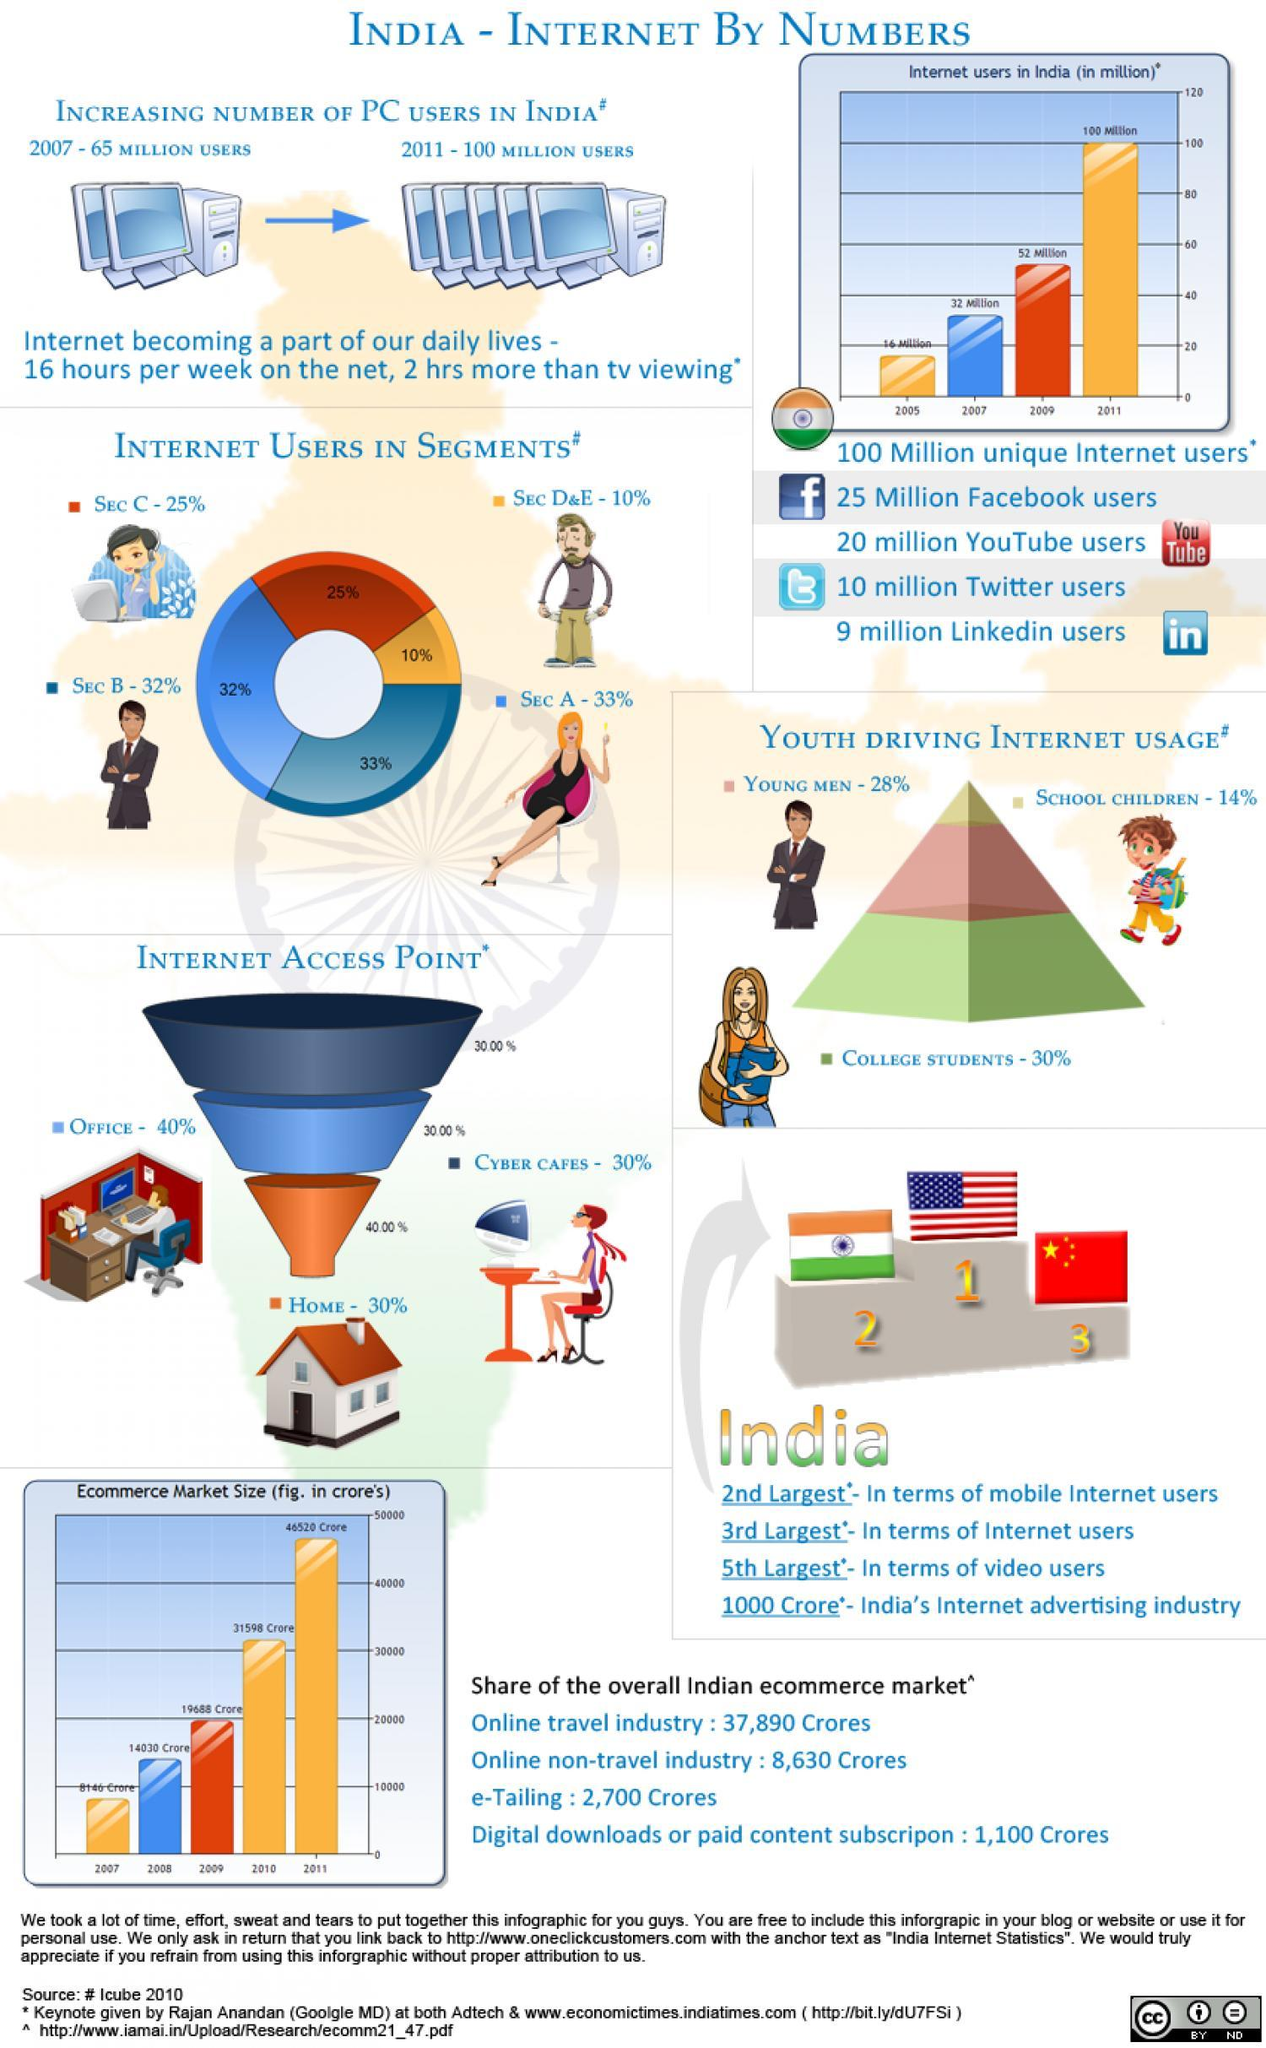What is the increase in the number of user from 2007 to 2011?
Answer the question with a short phrase. 35 Million Users What is the total percentage of users using internet at home and office? 70% What was the increase in number of internet users from 2009 to 2011? 48 Million Which segment has the highest percentage of internet users, Sec A, Sec D&E, or Sec B? Sec B What is the growth in ecommerce market size in crores from 2010 to 2011? 14,922 crores What was the increase in the number of internet users in India from 2007 to 2009? 20 Million Which country is the first largest in terms of internet users, China, India, or USA? USA 